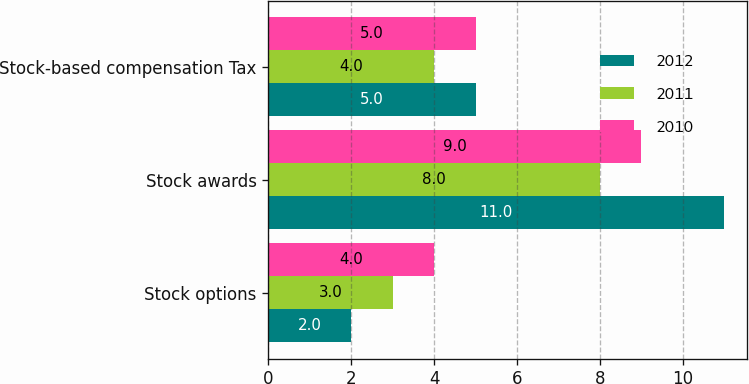Convert chart. <chart><loc_0><loc_0><loc_500><loc_500><stacked_bar_chart><ecel><fcel>Stock options<fcel>Stock awards<fcel>Stock-based compensation Tax<nl><fcel>2012<fcel>2<fcel>11<fcel>5<nl><fcel>2011<fcel>3<fcel>8<fcel>4<nl><fcel>2010<fcel>4<fcel>9<fcel>5<nl></chart> 